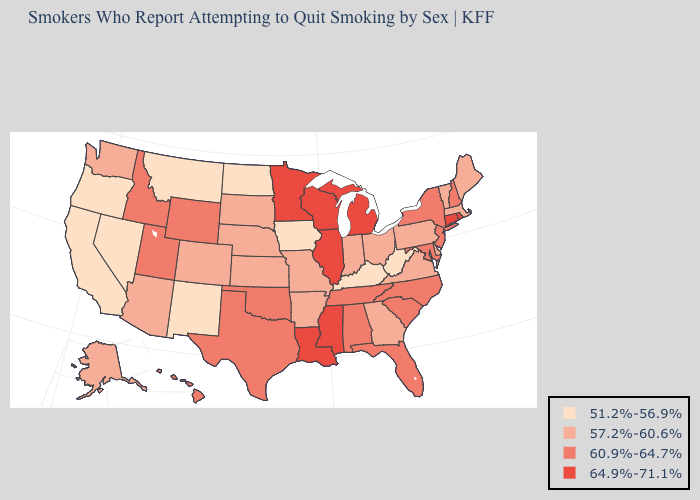What is the lowest value in states that border Illinois?
Quick response, please. 51.2%-56.9%. Name the states that have a value in the range 51.2%-56.9%?
Concise answer only. California, Iowa, Kentucky, Montana, Nevada, New Mexico, North Dakota, Oregon, West Virginia. What is the value of Wyoming?
Be succinct. 60.9%-64.7%. Among the states that border Idaho , which have the highest value?
Give a very brief answer. Utah, Wyoming. What is the highest value in the South ?
Give a very brief answer. 64.9%-71.1%. What is the lowest value in the USA?
Short answer required. 51.2%-56.9%. What is the highest value in the Northeast ?
Quick response, please. 64.9%-71.1%. Which states have the highest value in the USA?
Give a very brief answer. Connecticut, Illinois, Louisiana, Michigan, Minnesota, Mississippi, Rhode Island, Wisconsin. What is the value of Louisiana?
Be succinct. 64.9%-71.1%. Name the states that have a value in the range 57.2%-60.6%?
Give a very brief answer. Alaska, Arizona, Arkansas, Colorado, Delaware, Georgia, Indiana, Kansas, Maine, Massachusetts, Missouri, Nebraska, Ohio, Pennsylvania, South Dakota, Vermont, Virginia, Washington. Does Ohio have a higher value than California?
Give a very brief answer. Yes. Does the first symbol in the legend represent the smallest category?
Keep it brief. Yes. Does Kentucky have the lowest value in the South?
Give a very brief answer. Yes. What is the value of Illinois?
Keep it brief. 64.9%-71.1%. 